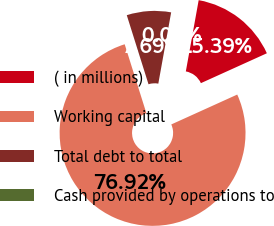Convert chart to OTSL. <chart><loc_0><loc_0><loc_500><loc_500><pie_chart><fcel>( in millions)<fcel>Working capital<fcel>Total debt to total<fcel>Cash provided by operations to<nl><fcel>15.39%<fcel>76.92%<fcel>7.69%<fcel>0.0%<nl></chart> 